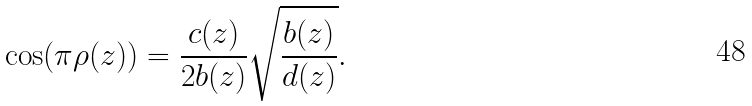Convert formula to latex. <formula><loc_0><loc_0><loc_500><loc_500>\cos ( \pi \rho ( z ) ) = \frac { c ( z ) } { 2 b ( z ) } \sqrt { \frac { b ( z ) } { d ( z ) } } .</formula> 